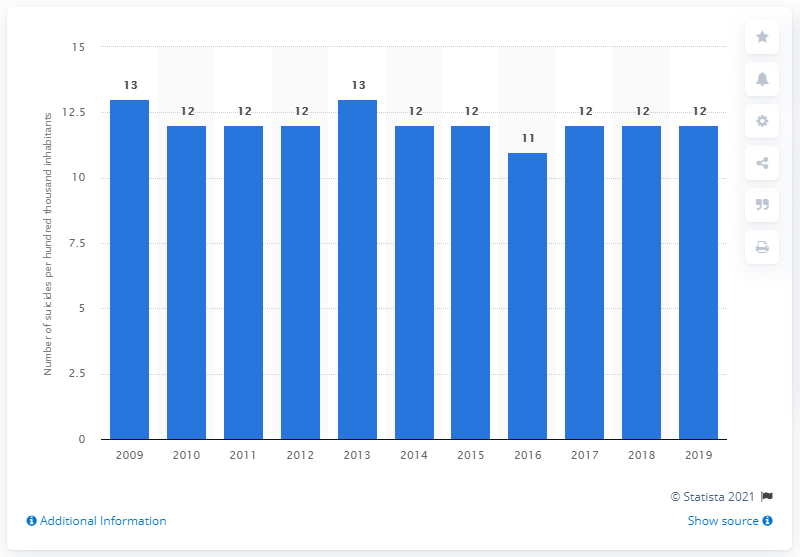Give some essential details in this illustration. In 2019, there were 12 suicides per hundred thousand inhabitants in Sweden. 